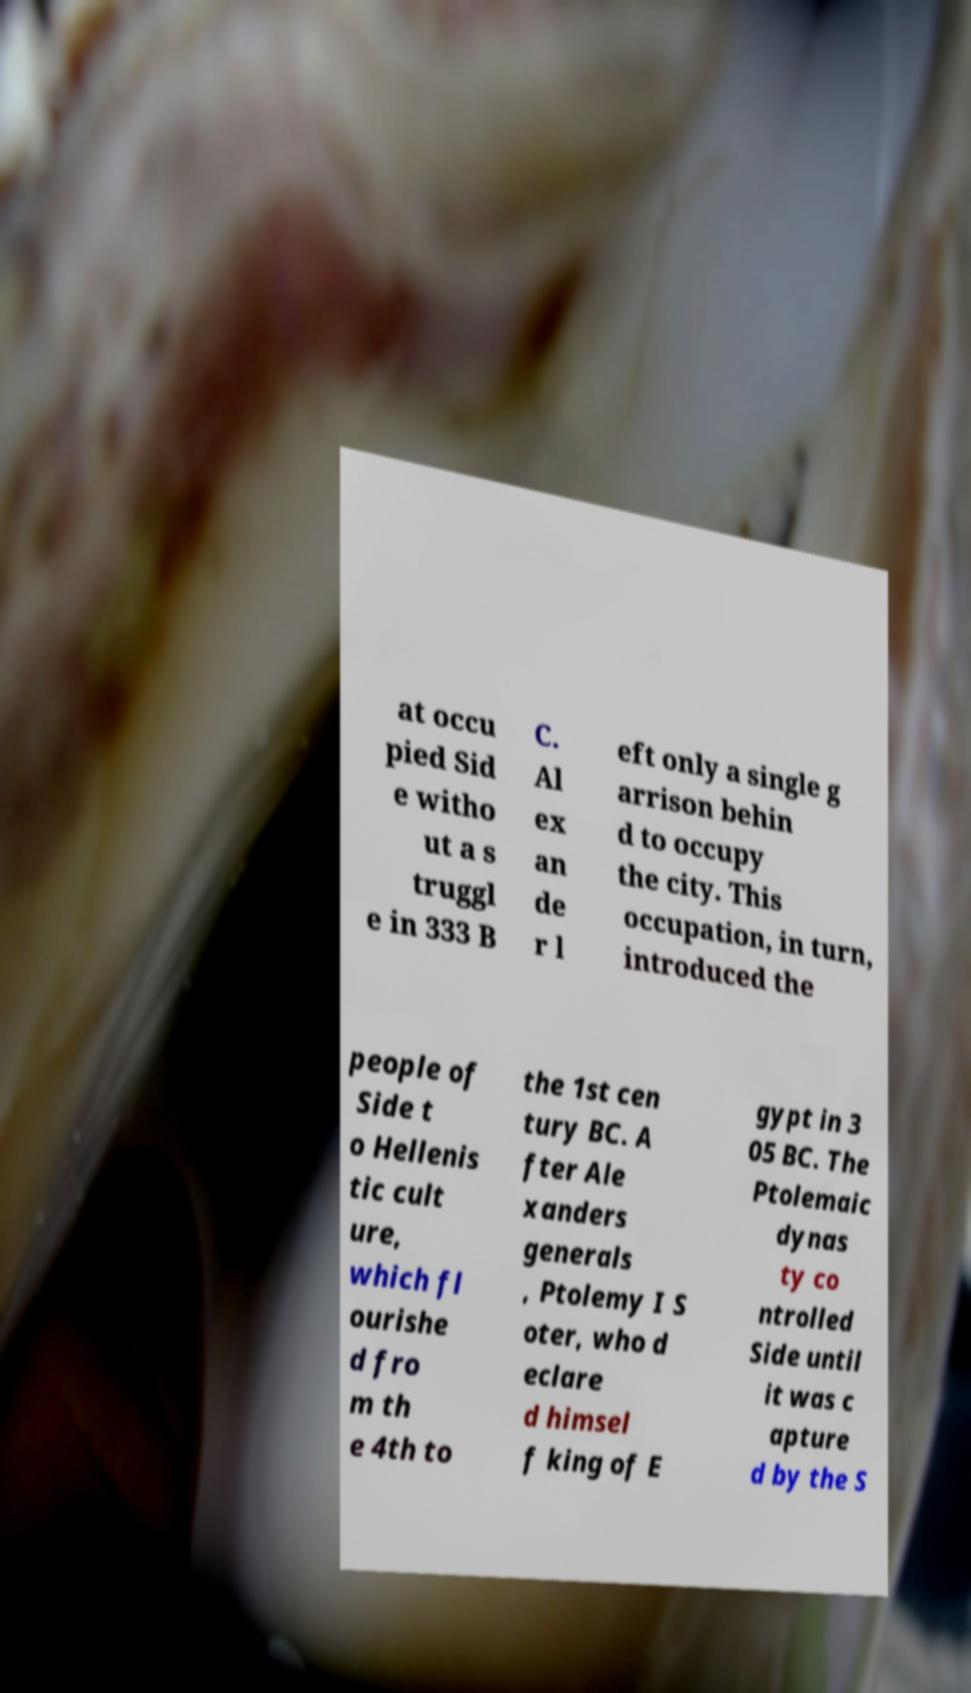I need the written content from this picture converted into text. Can you do that? at occu pied Sid e witho ut a s truggl e in 333 B C. Al ex an de r l eft only a single g arrison behin d to occupy the city. This occupation, in turn, introduced the people of Side t o Hellenis tic cult ure, which fl ourishe d fro m th e 4th to the 1st cen tury BC. A fter Ale xanders generals , Ptolemy I S oter, who d eclare d himsel f king of E gypt in 3 05 BC. The Ptolemaic dynas ty co ntrolled Side until it was c apture d by the S 